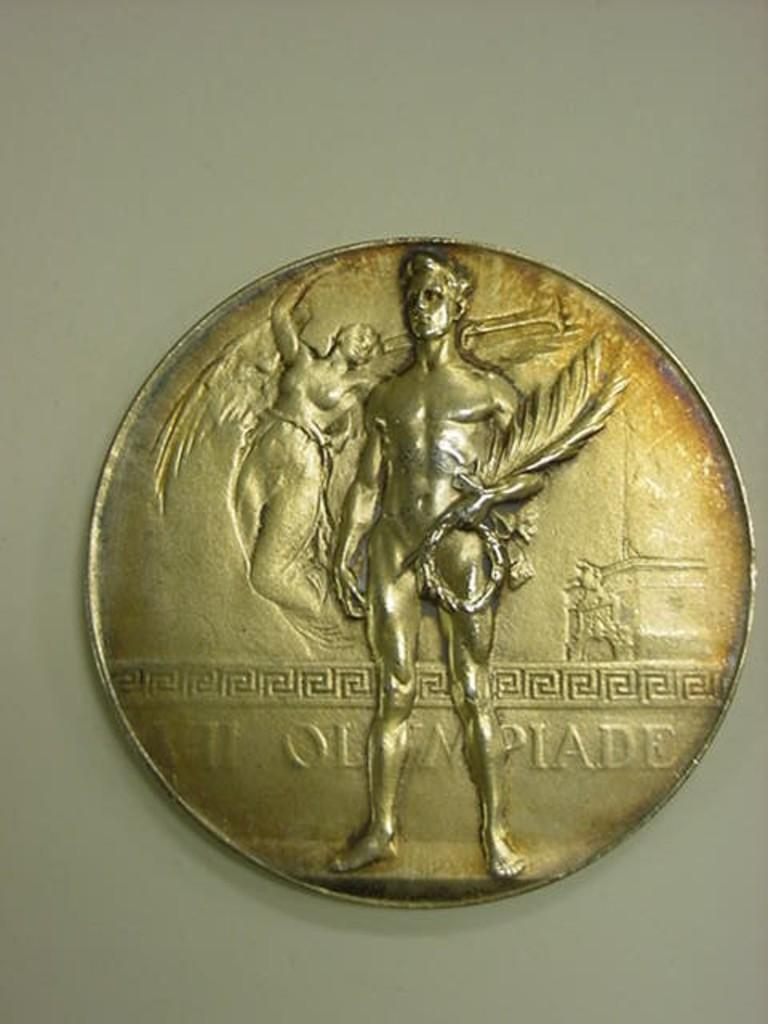<image>
Describe the image concisely. a coin that says VII OLEMPIADE on it in gold 